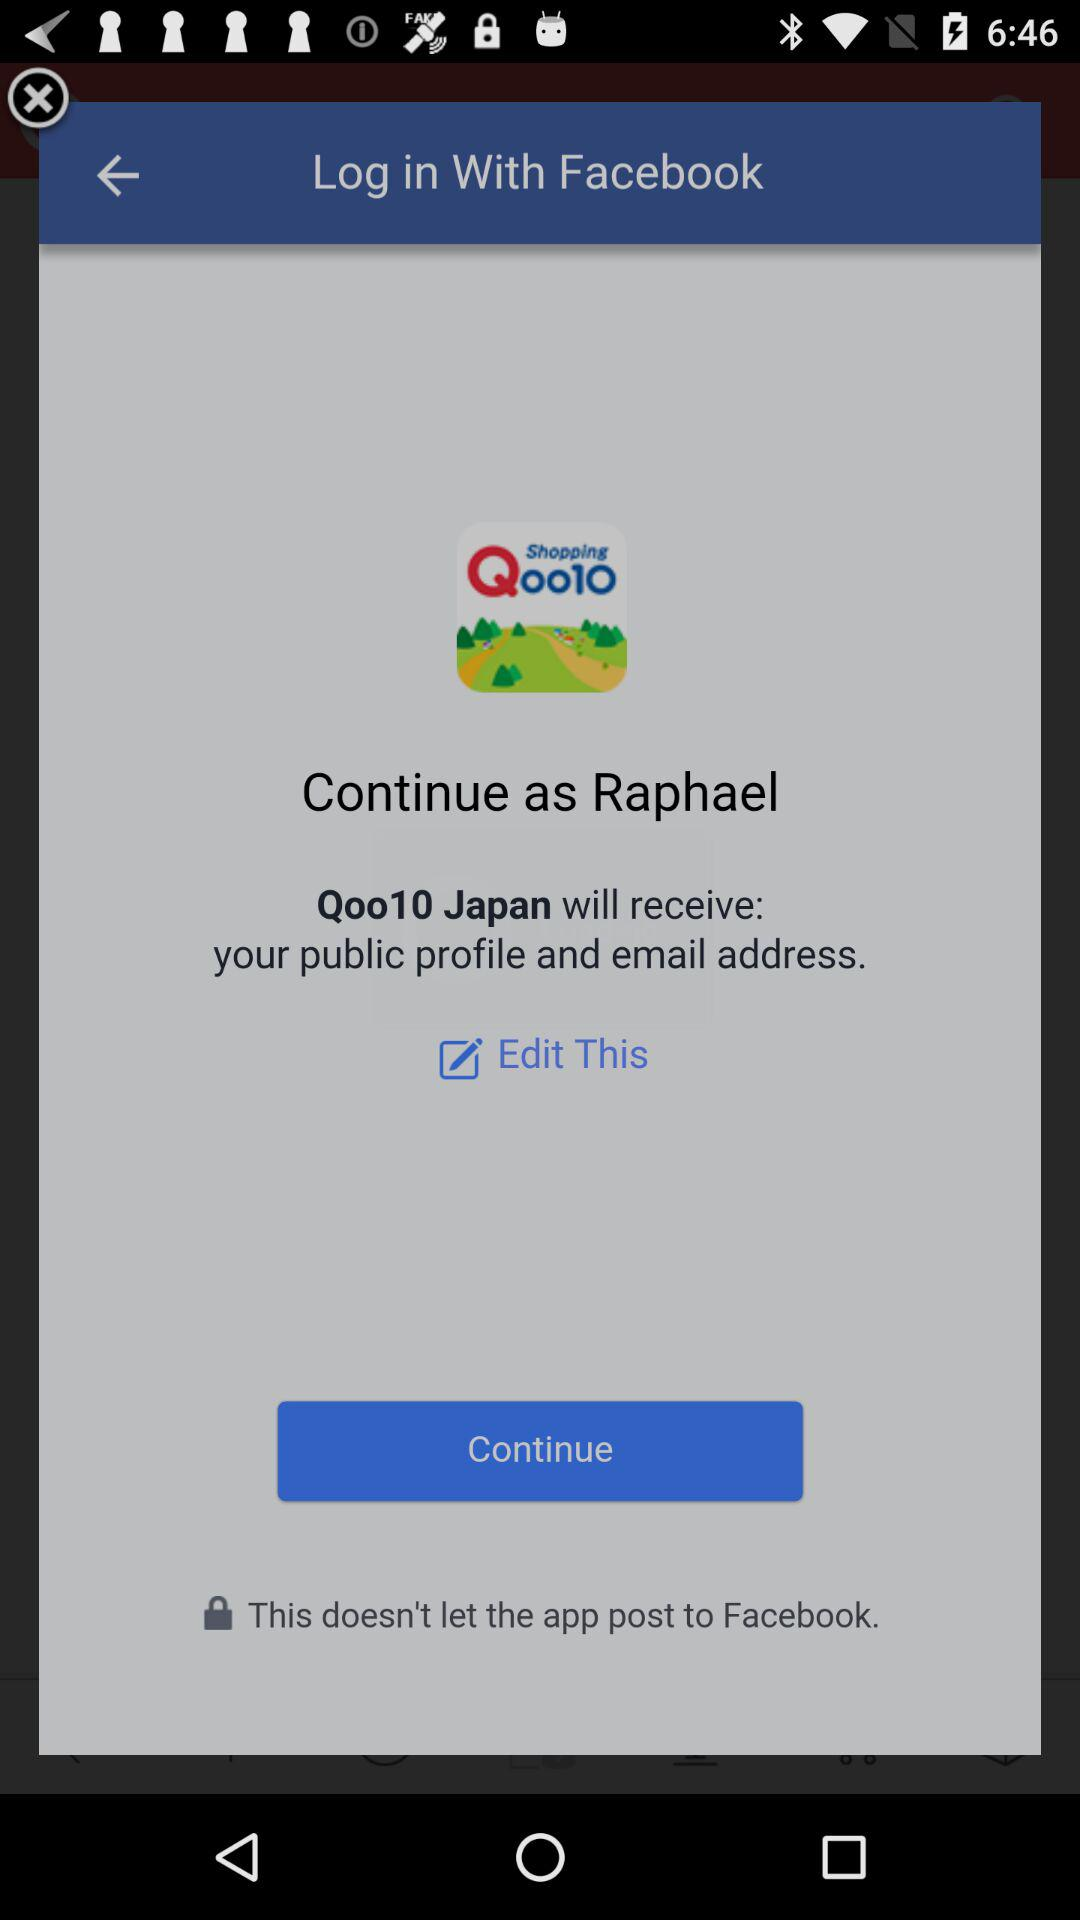Through what application can we log in? You can log in through "Facebook". 